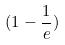<formula> <loc_0><loc_0><loc_500><loc_500>( 1 - \frac { 1 } { e } )</formula> 